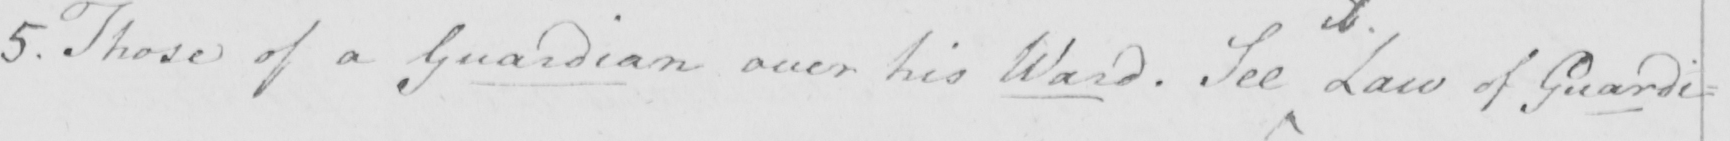What does this handwritten line say? 5 . Those of a Guardian over his Ward  . See Law of Guardi : 